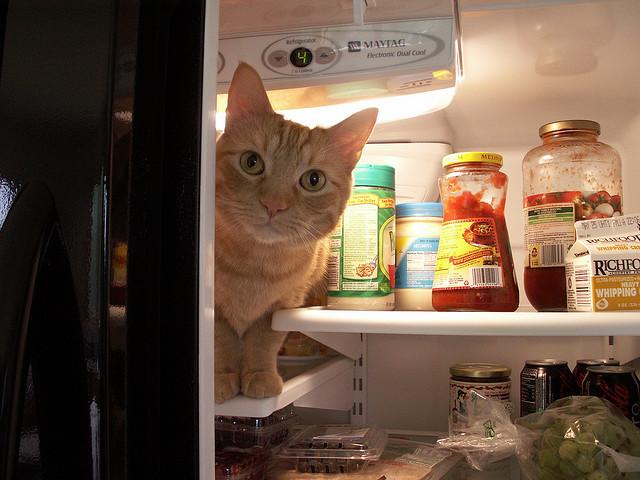What is in the picture?
Quick response, please. Cat. What kind of appliance is the cat standing in?
Keep it brief. Refrigerator. What is the name of the refrigerator?
Quick response, please. Maytag. What is in the small carton?
Be succinct. Whipping cream. 